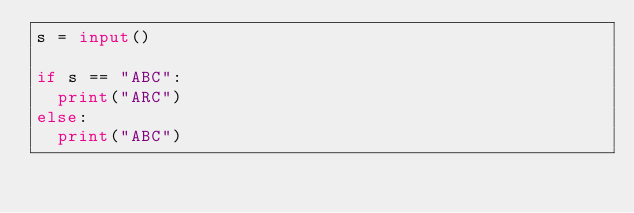Convert code to text. <code><loc_0><loc_0><loc_500><loc_500><_Python_>s = input()

if s == "ABC":
  print("ARC")
else:
  print("ABC")</code> 